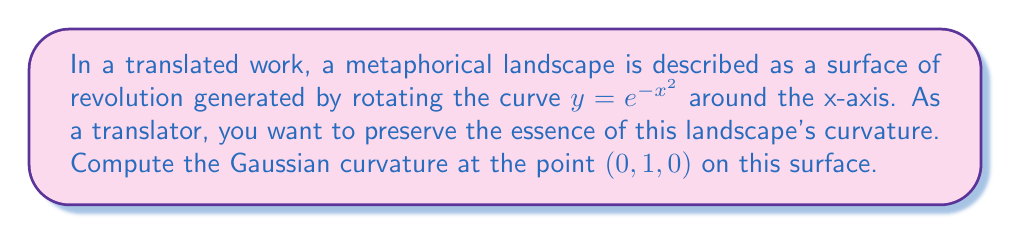Show me your answer to this math problem. To compute the Gaussian curvature of this surface of revolution, we'll follow these steps:

1) For a surface of revolution generated by rotating $y = f(x)$ around the x-axis, the Gaussian curvature K is given by:

   $$K = -\frac{f''(x)}{f(x)[1 + (f'(x))^2]}$$

2) In our case, $f(x) = e^{-x^2}$. Let's calculate $f'(x)$ and $f''(x)$:

   $f'(x) = -2xe^{-x^2}$
   $f''(x) = (-2 + 4x^2)e^{-x^2}$

3) At the point $(0, 1, 0)$, $x = 0$. Let's evaluate $f(0)$, $f'(0)$, and $f''(0)$:

   $f(0) = e^0 = 1$
   $f'(0) = 0$
   $f''(0) = -2e^0 = -2$

4) Now, let's substitute these values into the formula for K:

   $$K = -\frac{f''(0)}{f(0)[1 + (f'(0))^2]}$$

   $$K = -\frac{-2}{1[1 + 0^2]}$$

   $$K = -\frac{-2}{1} = 2$$

Therefore, the Gaussian curvature at the point $(0, 1, 0)$ is 2.
Answer: $2$ 